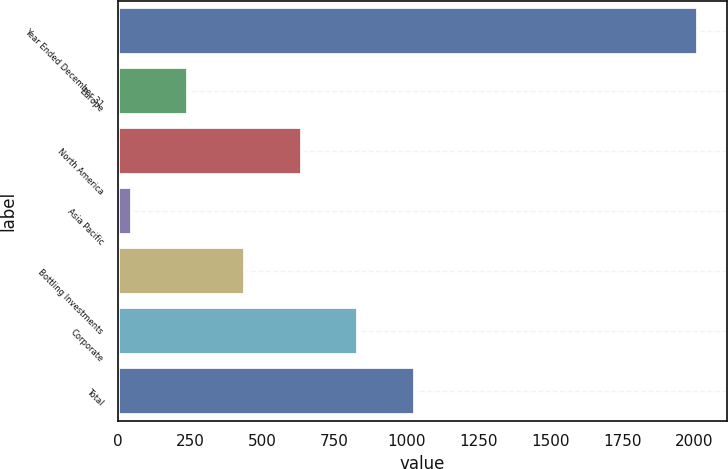<chart> <loc_0><loc_0><loc_500><loc_500><bar_chart><fcel>Year Ended December 31<fcel>Europe<fcel>North America<fcel>Asia Pacific<fcel>Bottling Investments<fcel>Corporate<fcel>Total<nl><fcel>2013<fcel>243.6<fcel>636.8<fcel>47<fcel>440.2<fcel>833.4<fcel>1030<nl></chart> 